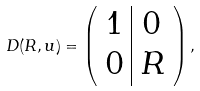<formula> <loc_0><loc_0><loc_500><loc_500>D ( R , u ) = \left ( \begin{array} { c | c } 1 & 0 \\ 0 & R \end{array} \right ) ,</formula> 